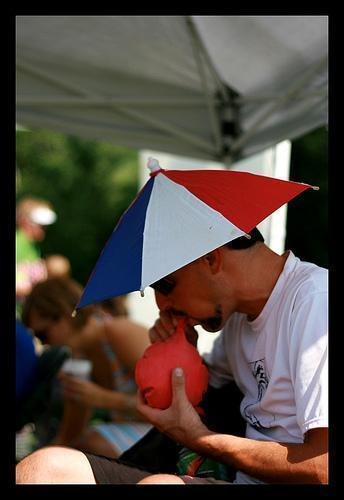How many people can you see?
Give a very brief answer. 3. How many blue cars are there?
Give a very brief answer. 0. 